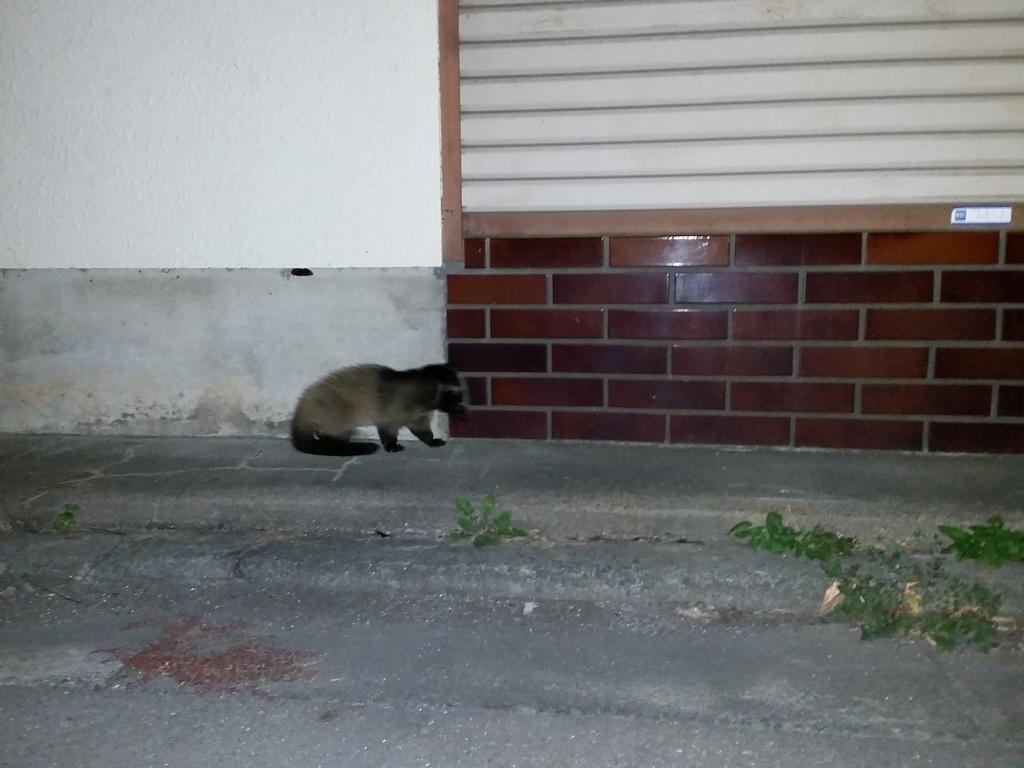How would you summarize this image in a sentence or two? In this image we can see an animal on the ground. In the background, we can see the wall with ventilation. 